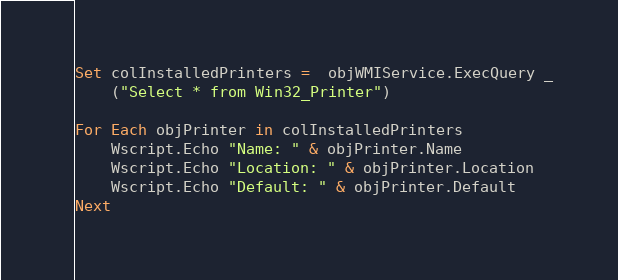<code> <loc_0><loc_0><loc_500><loc_500><_VisualBasic_>Set colInstalledPrinters =  objWMIService.ExecQuery _
    ("Select * from Win32_Printer")

For Each objPrinter in colInstalledPrinters
    Wscript.Echo "Name: " & objPrinter.Name
    Wscript.Echo "Location: " & objPrinter.Location
    Wscript.Echo "Default: " & objPrinter.Default
Next
</code> 